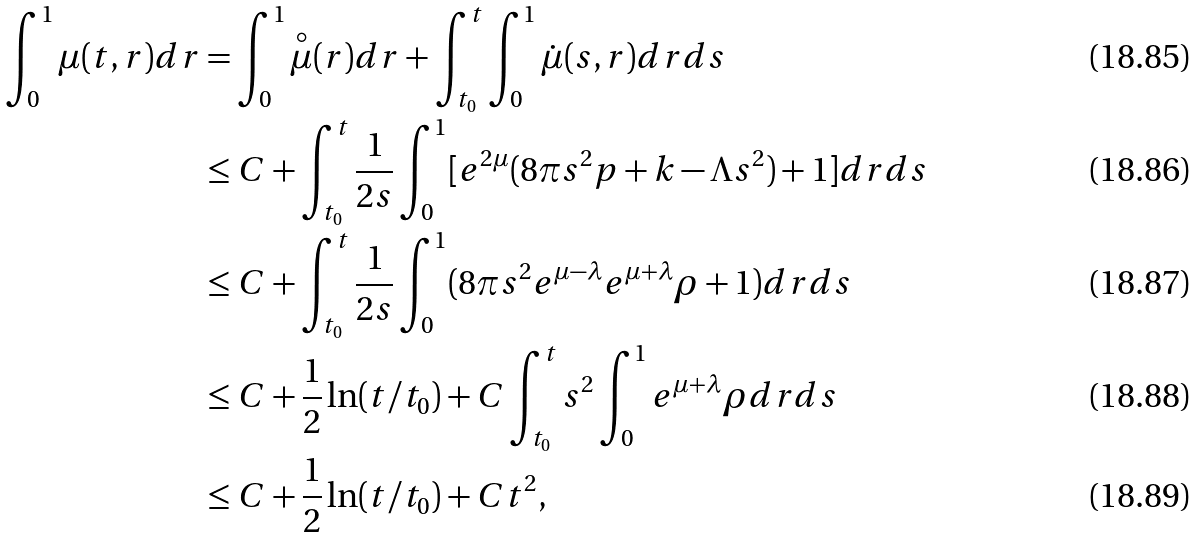<formula> <loc_0><loc_0><loc_500><loc_500>\int _ { 0 } ^ { 1 } \mu ( t , r ) d r & = \int _ { 0 } ^ { 1 } \overset { \circ } { \mu } ( r ) d r + \int _ { t _ { 0 } } ^ { t } \int _ { 0 } ^ { 1 } \dot { \mu } ( s , r ) d r d s \\ & \leq C + \int _ { t _ { 0 } } ^ { t } \frac { 1 } { 2 s } \int _ { 0 } ^ { 1 } [ e ^ { 2 \mu } ( 8 \pi s ^ { 2 } p + k - \Lambda s ^ { 2 } ) + 1 ] d r d s \\ & \leq C + \int _ { t _ { 0 } } ^ { t } \frac { 1 } { 2 s } \int _ { 0 } ^ { 1 } ( 8 \pi s ^ { 2 } e ^ { \mu - \lambda } e ^ { \mu + \lambda } \rho + 1 ) d r d s \\ & \leq C + \frac { 1 } { 2 } \ln ( t / t _ { 0 } ) + C \int _ { t _ { 0 } } ^ { t } s ^ { 2 } \int _ { 0 } ^ { 1 } e ^ { \mu + \lambda } \rho d r d s \\ & \leq C + \frac { 1 } { 2 } \ln ( t / t _ { 0 } ) + C t ^ { 2 } ,</formula> 